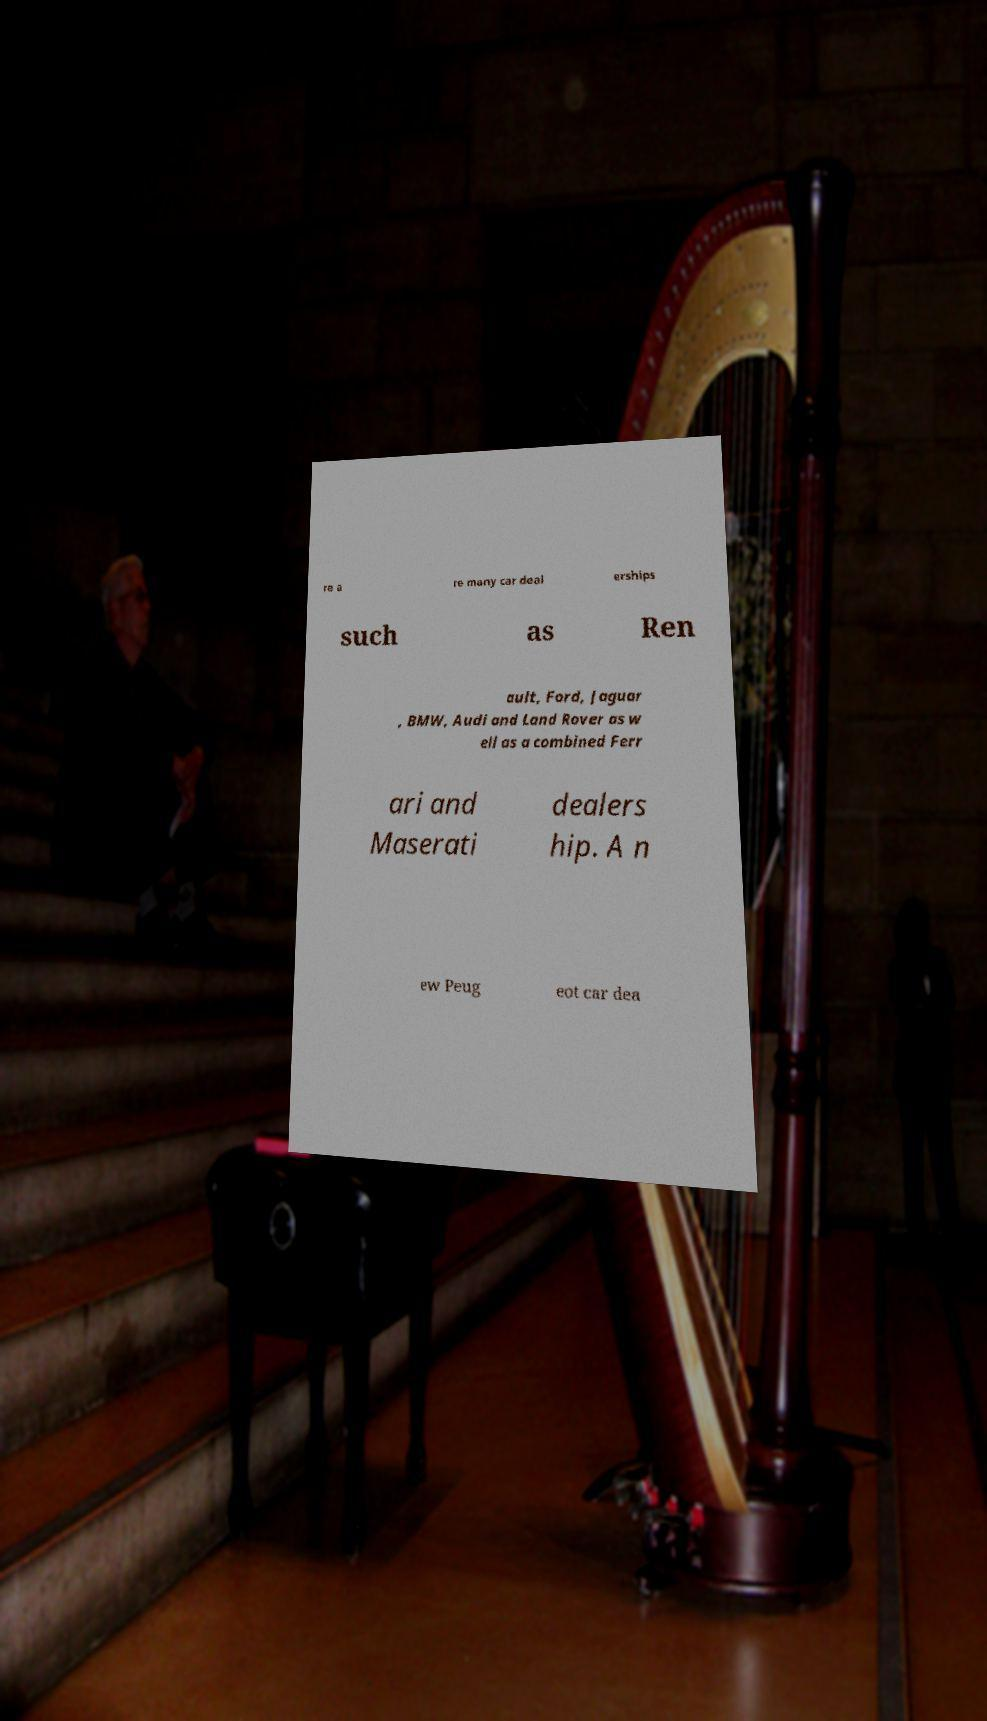Could you extract and type out the text from this image? re a re many car deal erships such as Ren ault, Ford, Jaguar , BMW, Audi and Land Rover as w ell as a combined Ferr ari and Maserati dealers hip. A n ew Peug eot car dea 